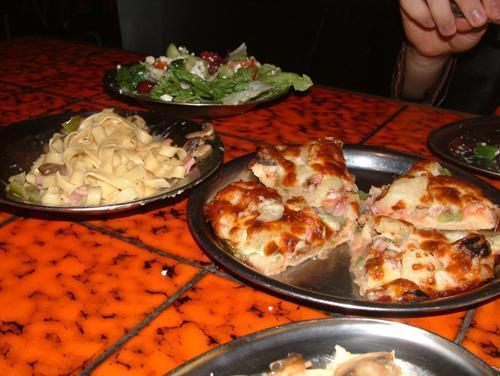How many grey bears are in the picture?
Give a very brief answer. 0. 